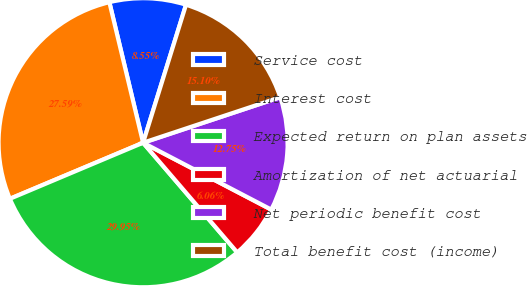<chart> <loc_0><loc_0><loc_500><loc_500><pie_chart><fcel>Service cost<fcel>Interest cost<fcel>Expected return on plan assets<fcel>Amortization of net actuarial<fcel>Net periodic benefit cost<fcel>Total benefit cost (income)<nl><fcel>8.55%<fcel>27.59%<fcel>29.95%<fcel>6.06%<fcel>12.75%<fcel>15.1%<nl></chart> 